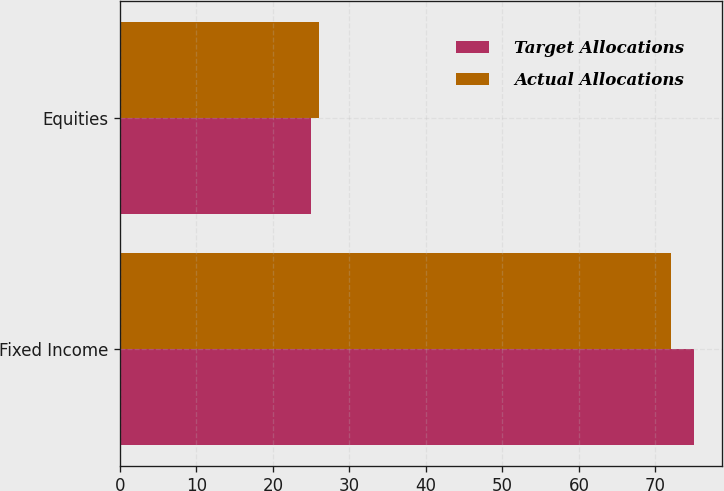<chart> <loc_0><loc_0><loc_500><loc_500><stacked_bar_chart><ecel><fcel>Fixed Income<fcel>Equities<nl><fcel>Target Allocations<fcel>75<fcel>25<nl><fcel>Actual Allocations<fcel>72<fcel>26<nl></chart> 